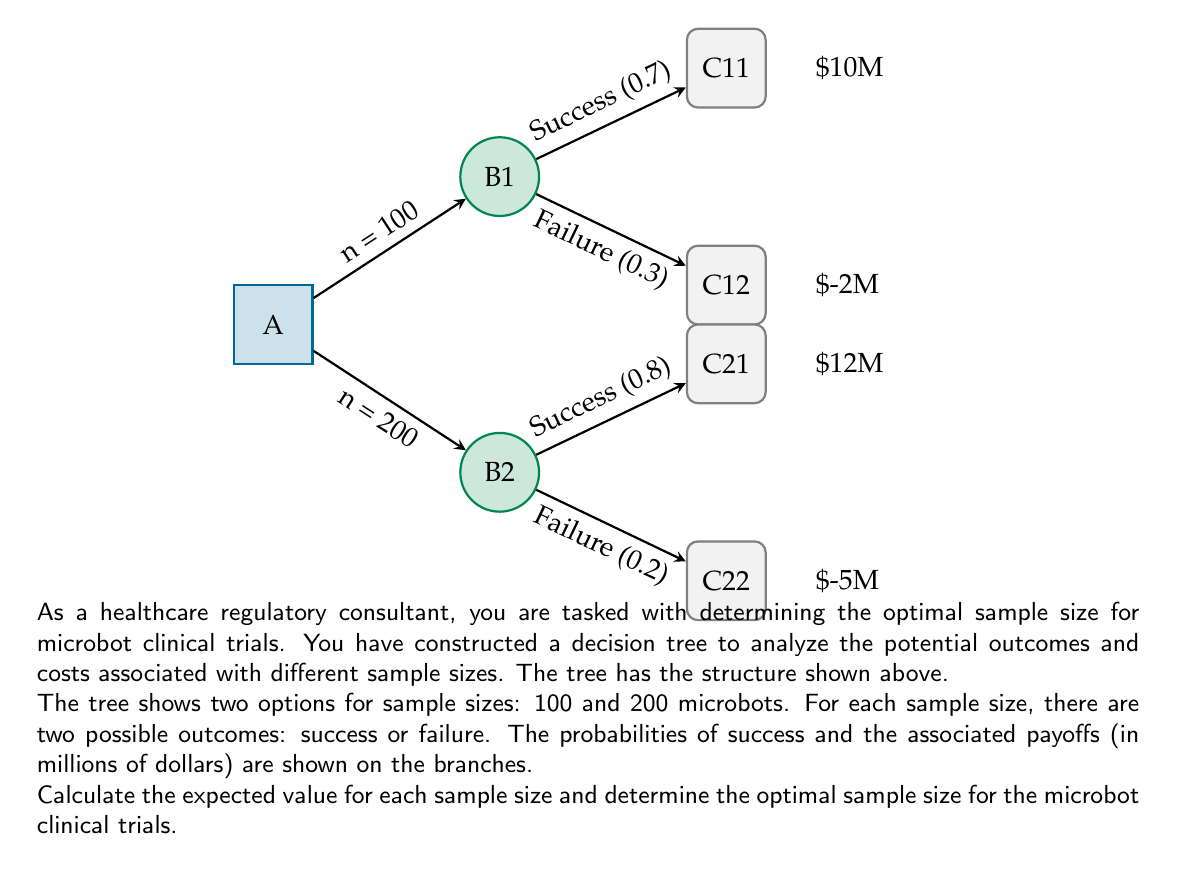Give your solution to this math problem. To solve this problem, we'll calculate the expected value for each sample size using the decision tree and compare them:

1. For n = 100:
   - Success probability: 0.7, Payoff: $10M
   - Failure probability: 0.3, Payoff: $-2M
   Expected Value = $$(0.7 \times 10) + (0.3 \times -2)$$
                  = $$7 - 0.6$$
                  = $$6.4$$ million

2. For n = 200:
   - Success probability: 0.8, Payoff: $12M
   - Failure probability: 0.2, Payoff: $-5M
   Expected Value = $$(0.8 \times 12) + (0.2 \times -5)$$
                  = $$9.6 - 1$$
                  = $$8.6$$ million

3. Compare the expected values:
   n = 100: $6.4 million
   n = 200: $8.6 million

The optimal sample size is the one with the higher expected value, which is 200 microbots.
Answer: 200 microbots 